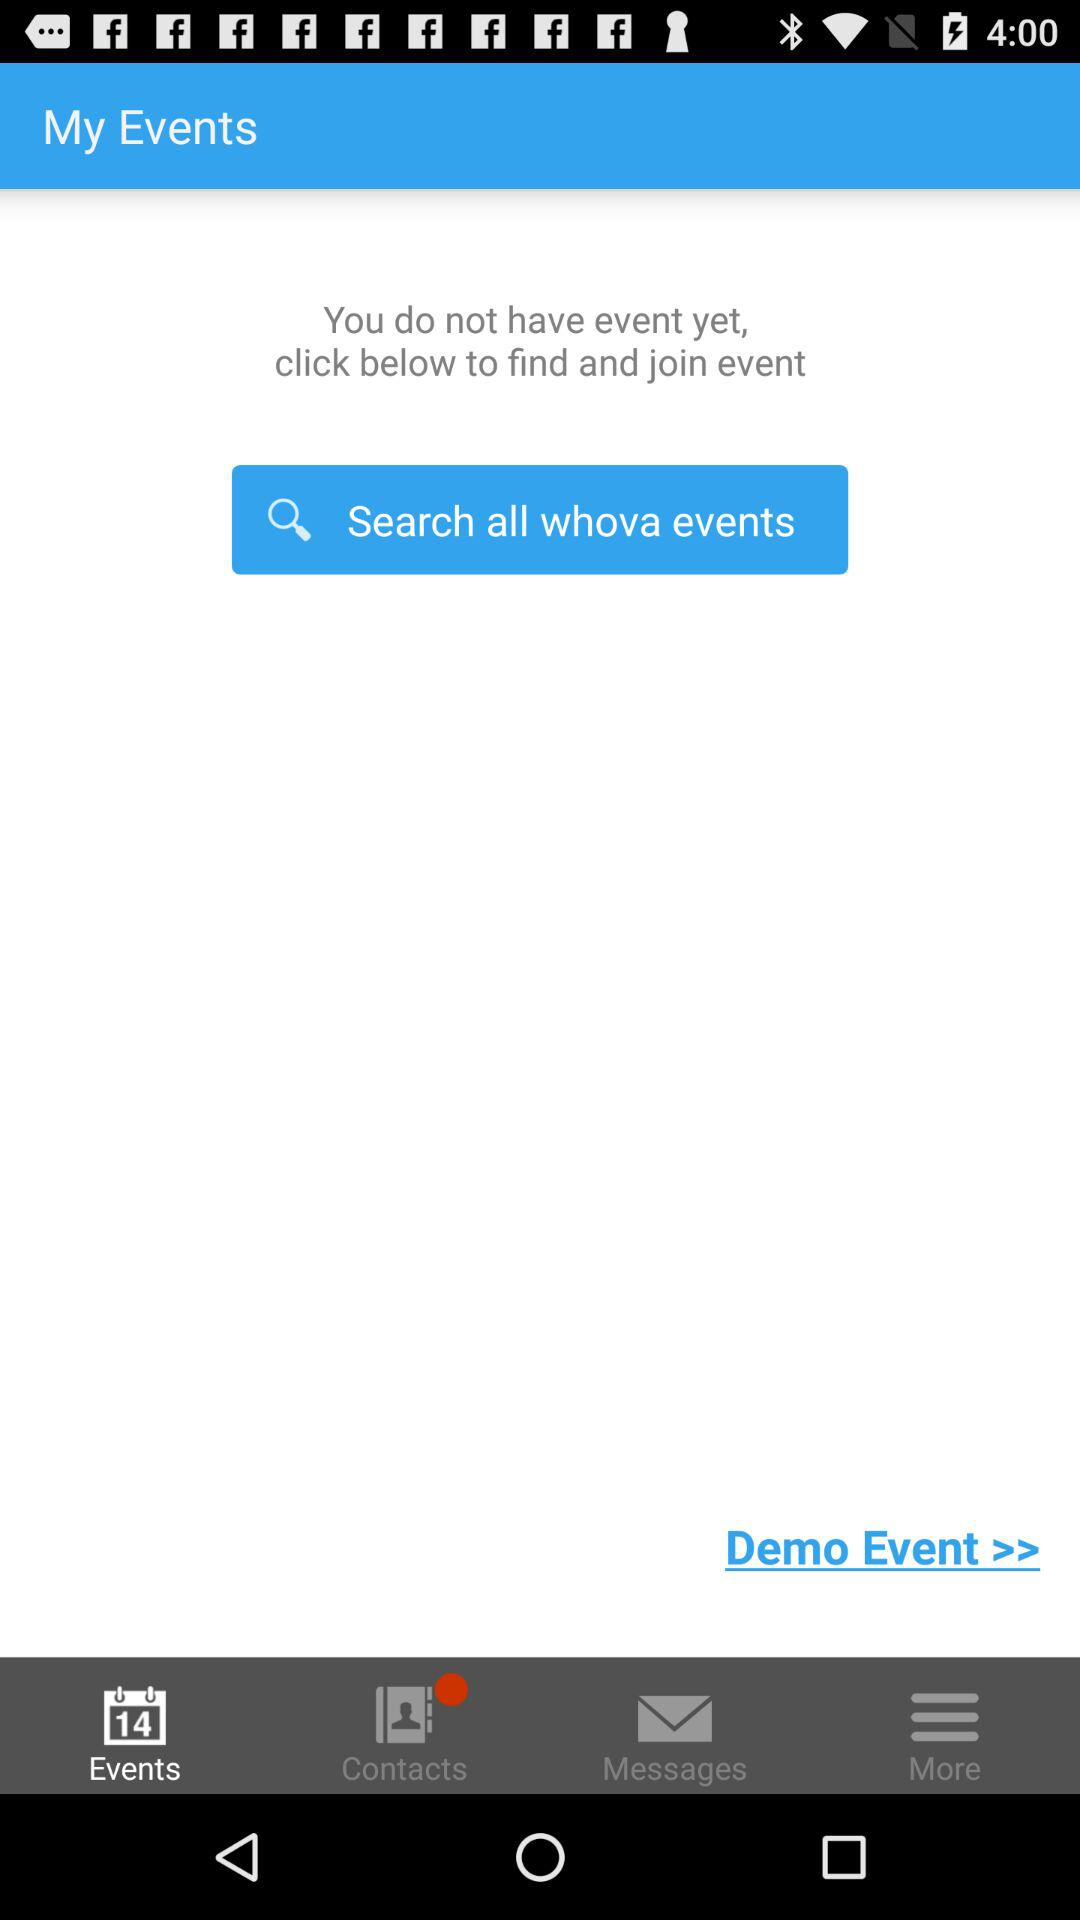Which tab is selected? The selected tab is "Events". 